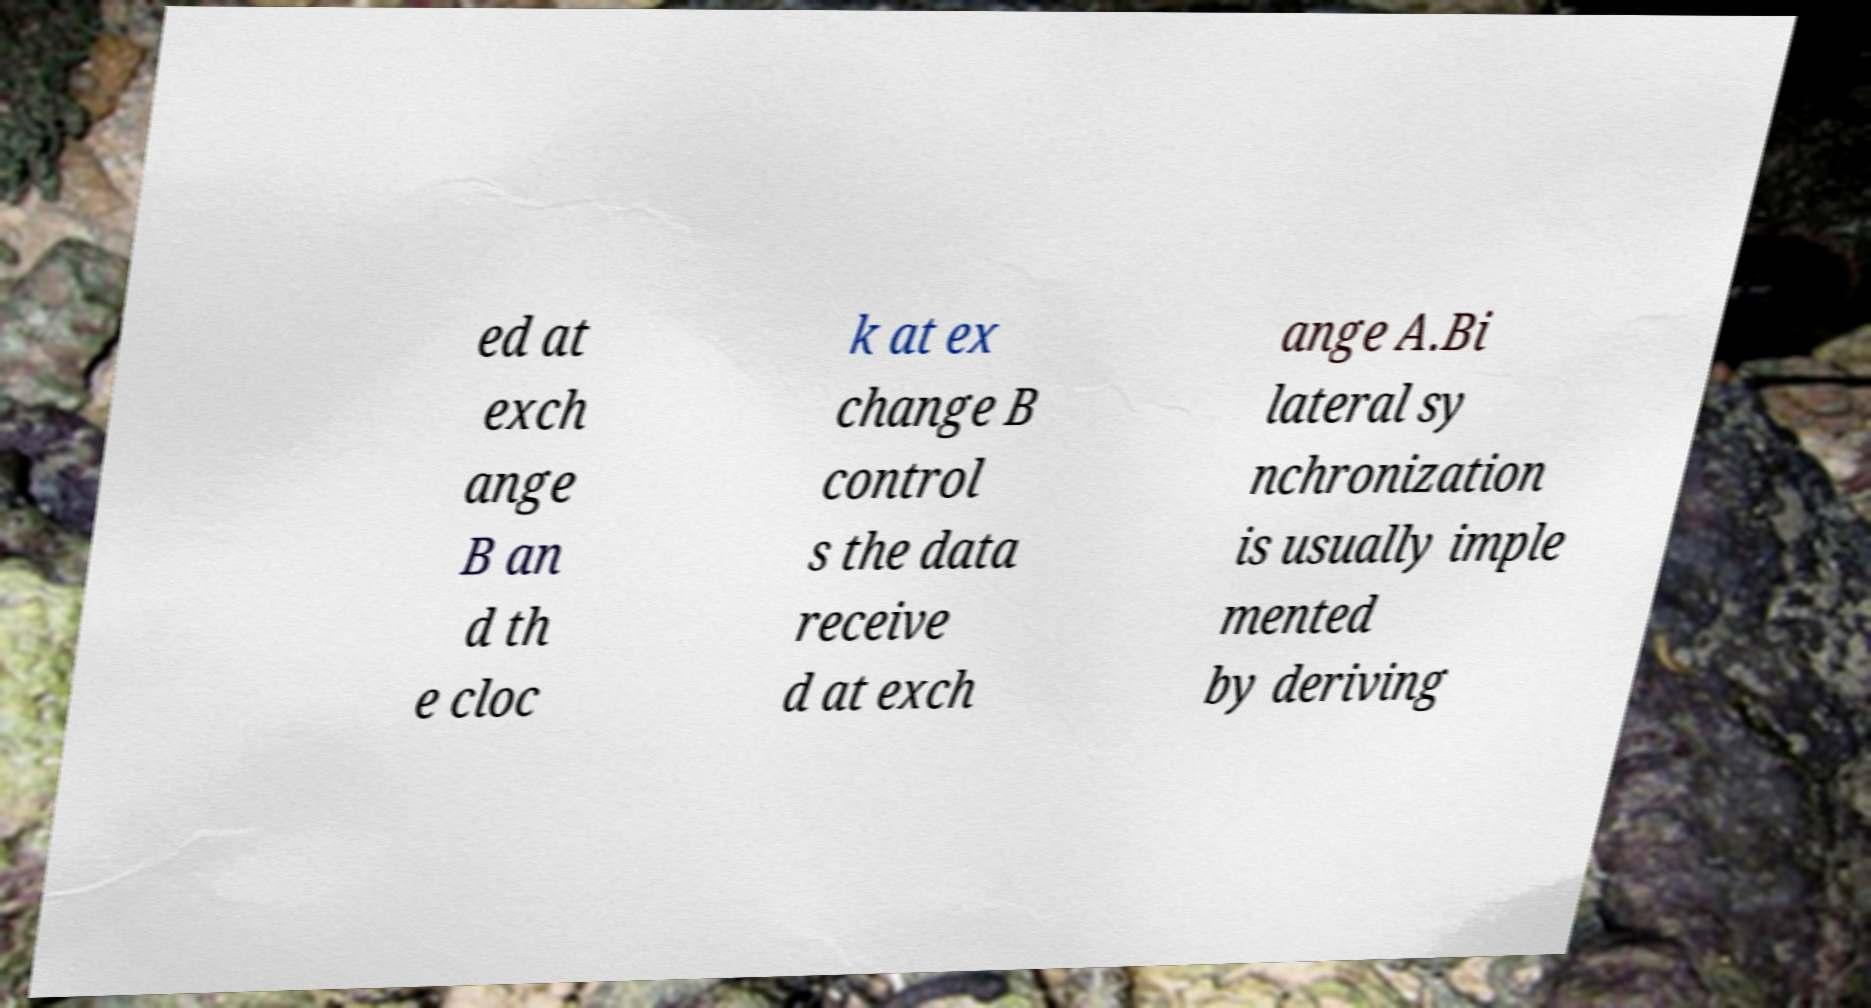There's text embedded in this image that I need extracted. Can you transcribe it verbatim? ed at exch ange B an d th e cloc k at ex change B control s the data receive d at exch ange A.Bi lateral sy nchronization is usually imple mented by deriving 